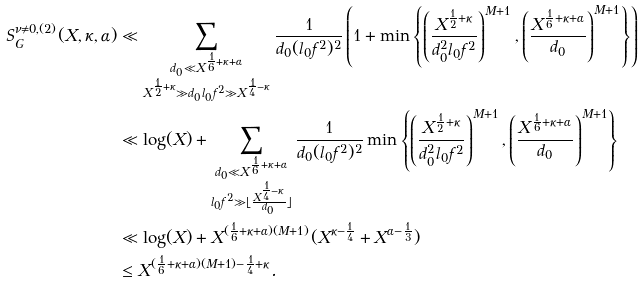<formula> <loc_0><loc_0><loc_500><loc_500>S _ { G } ^ { \nu \neq 0 , ( 2 ) } ( X , \kappa , \alpha ) & \ll \sum _ { \substack { d _ { 0 } \ll X ^ { \frac { 1 } { 6 } + \kappa + \alpha } \\ X ^ { \frac { 1 } { 2 } + \kappa } \gg d _ { 0 } l _ { 0 } f ^ { 2 } \gg X ^ { \frac { 1 } { 4 } - \kappa } } } \frac { 1 } { d _ { 0 } ( l _ { 0 } f ^ { 2 } ) ^ { 2 } } \left ( 1 + \min \left \{ \left ( \frac { X ^ { \frac { 1 } { 2 } + \kappa } } { d _ { 0 } ^ { 2 } l _ { 0 } f ^ { 2 } } \right ) ^ { M + 1 } , \left ( \frac { X ^ { \frac { 1 } { 6 } + \kappa + \alpha } } { d _ { 0 } } \right ) ^ { M + 1 } \right \} \right ) \\ & \ll \log ( X ) + \sum _ { \substack { d _ { 0 } \ll X ^ { \frac { 1 } { 6 } + \kappa + \alpha } \\ l _ { 0 } f ^ { 2 } \gg \lfloor \frac { X ^ { \frac { 1 } { 4 } - \kappa } } { d _ { 0 } } \rfloor } } \frac { 1 } { d _ { 0 } ( l _ { 0 } f ^ { 2 } ) ^ { 2 } } \min \left \{ \left ( \frac { X ^ { \frac { 1 } { 2 } + \kappa } } { d _ { 0 } ^ { 2 } l _ { 0 } f ^ { 2 } } \right ) ^ { M + 1 } , \left ( \frac { X ^ { \frac { 1 } { 6 } + \kappa + \alpha } } { d _ { 0 } } \right ) ^ { M + 1 } \right \} \\ & \ll \log ( X ) + X ^ { ( \frac { 1 } { 6 } + \kappa + \alpha ) ( M + 1 ) } ( X ^ { \kappa - \frac { 1 } { 4 } } + X ^ { \alpha - \frac { 1 } { 3 } } ) \\ & \leq X ^ { ( \frac { 1 } { 6 } + \kappa + \alpha ) ( M + 1 ) - \frac { 1 } { 4 } + \kappa } .</formula> 